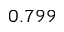Convert formula to latex. <formula><loc_0><loc_0><loc_500><loc_500>0 . 7 9 9</formula> 